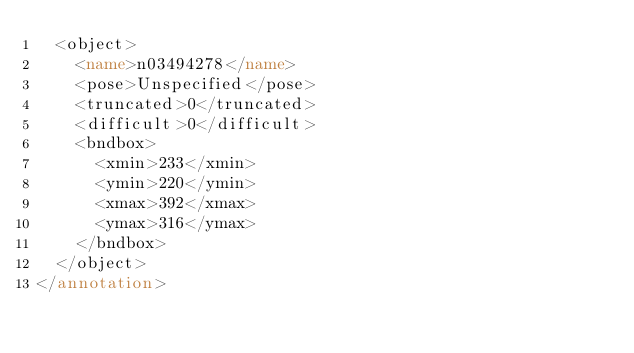Convert code to text. <code><loc_0><loc_0><loc_500><loc_500><_XML_>	<object>
		<name>n03494278</name>
		<pose>Unspecified</pose>
		<truncated>0</truncated>
		<difficult>0</difficult>
		<bndbox>
			<xmin>233</xmin>
			<ymin>220</ymin>
			<xmax>392</xmax>
			<ymax>316</ymax>
		</bndbox>
	</object>
</annotation></code> 